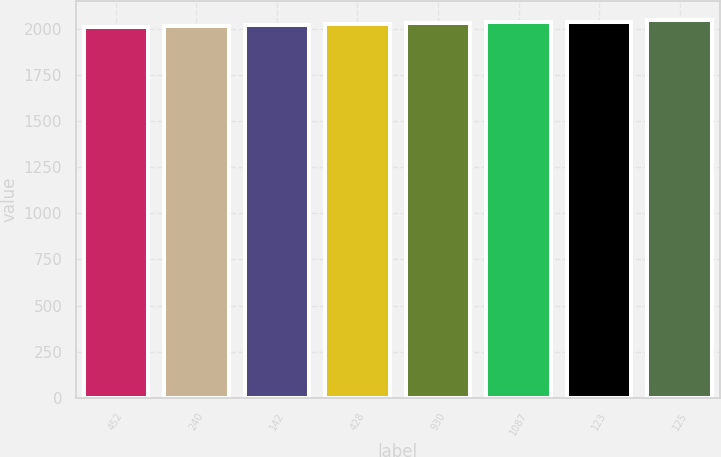<chart> <loc_0><loc_0><loc_500><loc_500><bar_chart><fcel>452<fcel>240<fcel>142<fcel>428<fcel>930<fcel>1087<fcel>123<fcel>125<nl><fcel>2012<fcel>2015.6<fcel>2019.2<fcel>2025<fcel>2031<fcel>2036<fcel>2039.6<fcel>2048<nl></chart> 